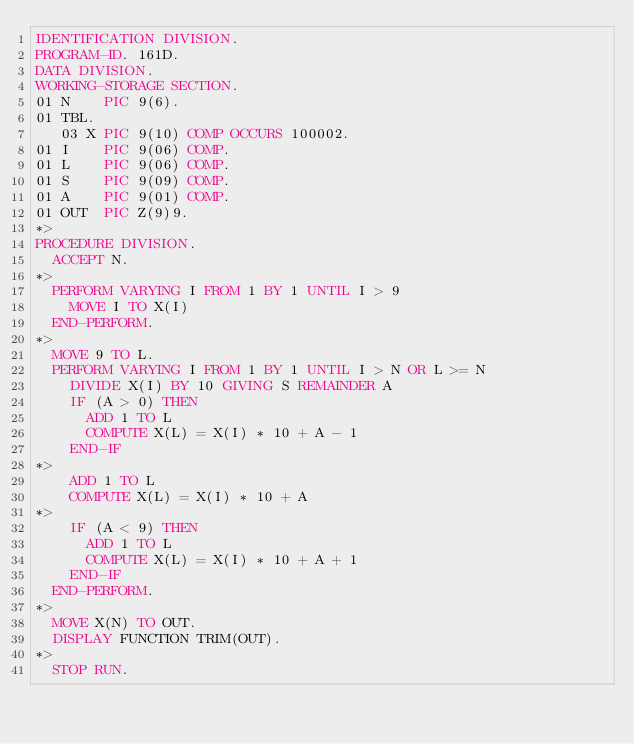Convert code to text. <code><loc_0><loc_0><loc_500><loc_500><_COBOL_>IDENTIFICATION DIVISION.
PROGRAM-ID. 161D.
DATA DIVISION.
WORKING-STORAGE SECTION.
01 N    PIC 9(6).
01 TBL.
   03 X PIC 9(10) COMP OCCURS 100002.
01 I    PIC 9(06) COMP.
01 L    PIC 9(06) COMP.
01 S    PIC 9(09) COMP.
01 A    PIC 9(01) COMP.
01 OUT  PIC Z(9)9.
*>  
PROCEDURE DIVISION.
  ACCEPT N.
*>
  PERFORM VARYING I FROM 1 BY 1 UNTIL I > 9
    MOVE I TO X(I)
  END-PERFORM.
*>
  MOVE 9 TO L.
  PERFORM VARYING I FROM 1 BY 1 UNTIL I > N OR L >= N
    DIVIDE X(I) BY 10 GIVING S REMAINDER A
    IF (A > 0) THEN
      ADD 1 TO L
      COMPUTE X(L) = X(I) * 10 + A - 1
    END-IF
*>
    ADD 1 TO L
    COMPUTE X(L) = X(I) * 10 + A
*>
    IF (A < 9) THEN
      ADD 1 TO L
      COMPUTE X(L) = X(I) * 10 + A + 1
    END-IF
  END-PERFORM.
*>
  MOVE X(N) TO OUT.
  DISPLAY FUNCTION TRIM(OUT).
*>
  STOP RUN.
 </code> 